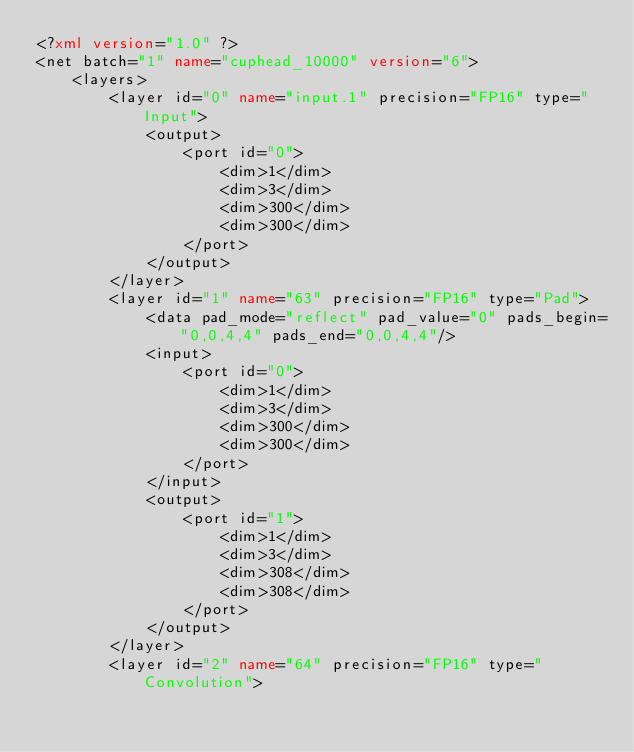<code> <loc_0><loc_0><loc_500><loc_500><_XML_><?xml version="1.0" ?>
<net batch="1" name="cuphead_10000" version="6">
	<layers>
		<layer id="0" name="input.1" precision="FP16" type="Input">
			<output>
				<port id="0">
					<dim>1</dim>
					<dim>3</dim>
					<dim>300</dim>
					<dim>300</dim>
				</port>
			</output>
		</layer>
		<layer id="1" name="63" precision="FP16" type="Pad">
			<data pad_mode="reflect" pad_value="0" pads_begin="0,0,4,4" pads_end="0,0,4,4"/>
			<input>
				<port id="0">
					<dim>1</dim>
					<dim>3</dim>
					<dim>300</dim>
					<dim>300</dim>
				</port>
			</input>
			<output>
				<port id="1">
					<dim>1</dim>
					<dim>3</dim>
					<dim>308</dim>
					<dim>308</dim>
				</port>
			</output>
		</layer>
		<layer id="2" name="64" precision="FP16" type="Convolution"></code> 